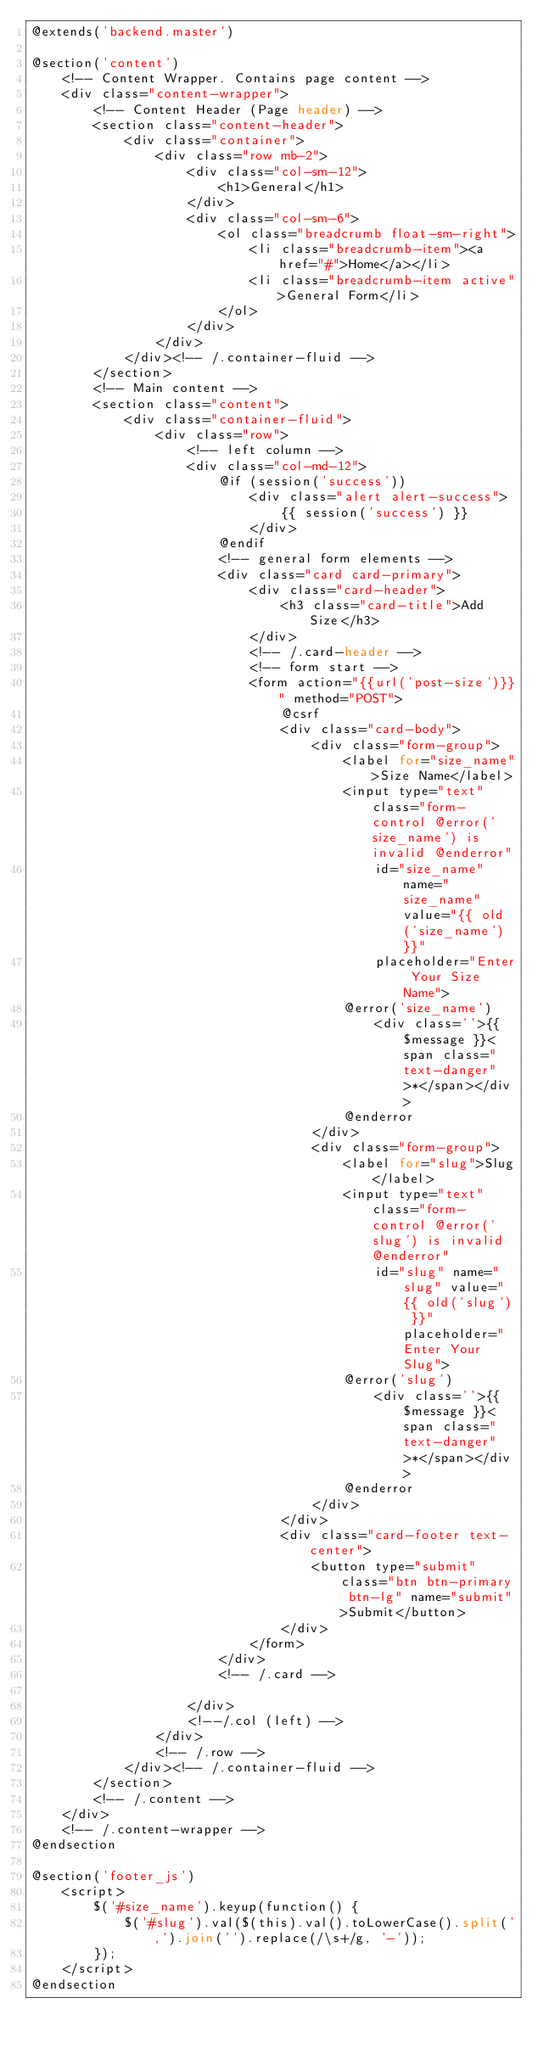<code> <loc_0><loc_0><loc_500><loc_500><_PHP_>@extends('backend.master')

@section('content')
    <!-- Content Wrapper. Contains page content -->
    <div class="content-wrapper">
        <!-- Content Header (Page header) -->
        <section class="content-header">
            <div class="container">
                <div class="row mb-2">
                    <div class="col-sm-12">
                        <h1>General</h1>
                    </div>
                    <div class="col-sm-6">
                        <ol class="breadcrumb float-sm-right">
                            <li class="breadcrumb-item"><a href="#">Home</a></li>
                            <li class="breadcrumb-item active">General Form</li>
                        </ol>
                    </div>
                </div>
            </div><!-- /.container-fluid -->
        </section>
        <!-- Main content -->
        <section class="content">
            <div class="container-fluid">
                <div class="row">
                    <!-- left column -->
                    <div class="col-md-12">
                        @if (session('success'))
                            <div class="alert alert-success">
                                {{ session('success') }}
                            </div>
                        @endif
                        <!-- general form elements -->
                        <div class="card card-primary">
                            <div class="card-header">
                                <h3 class="card-title">Add Size</h3>
                            </div>
                            <!-- /.card-header -->
                            <!-- form start -->
                            <form action="{{url('post-size')}}" method="POST">
                                @csrf
                                <div class="card-body">
                                    <div class="form-group">
                                        <label for="size_name">Size Name</label>
                                        <input type="text" class="form-control @error('size_name') is invalid @enderror"
                                            id="size_name" name="size_name" value="{{ old('size_name') }}"
                                            placeholder="Enter Your Size Name">
                                        @error('size_name')
                                            <div class=''>{{ $message }}<span class="text-danger">*</span></div>
                                        @enderror
                                    </div>
                                    <div class="form-group">
                                        <label for="slug">Slug</label> 
                                        <input type="text" class="form-control @error('slug') is invalid @enderror"
                                            id="slug" name="slug" value="{{ old('slug') }}" placeholder="Enter Your Slug">
                                        @error('slug')
                                            <div class=''>{{ $message }}<span class="text-danger">*</span></div>
                                        @enderror
                                    </div>
                                </div>
                                <div class="card-footer text-center">
                                    <button type="submit" class="btn btn-primary btn-lg" name="submit">Submit</button>
                                </div>
                            </form>
                        </div>
                        <!-- /.card -->

                    </div>
                    <!--/.col (left) -->
                </div>
                <!-- /.row -->
            </div><!-- /.container-fluid -->
        </section>
        <!-- /.content -->
    </div>
    <!-- /.content-wrapper -->
@endsection

@section('footer_js')
    <script>
        $('#size_name').keyup(function() {
            $('#slug').val($(this).val().toLowerCase().split(',').join('').replace(/\s+/g, '-'));
        });
    </script>
@endsection
</code> 